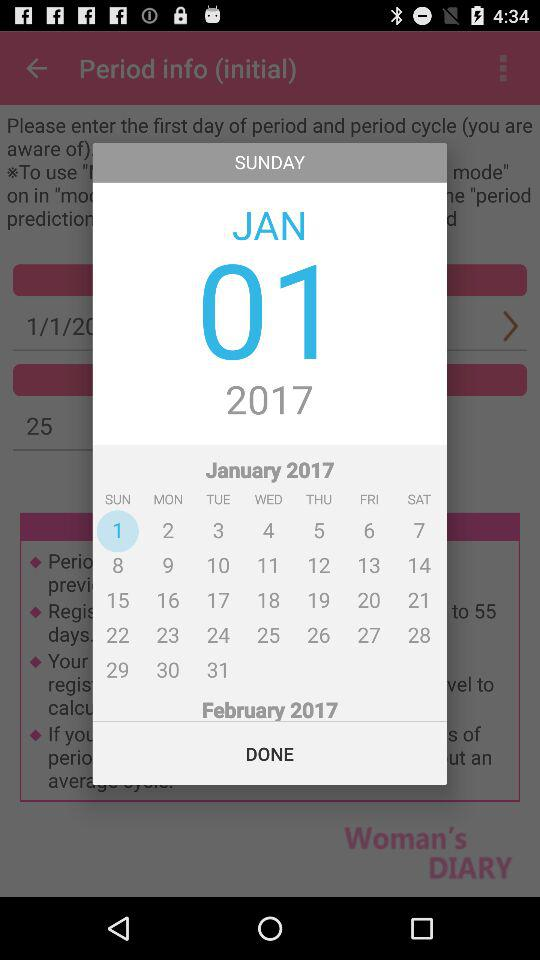What is the day on the 23rd of January? The day is Monday. 